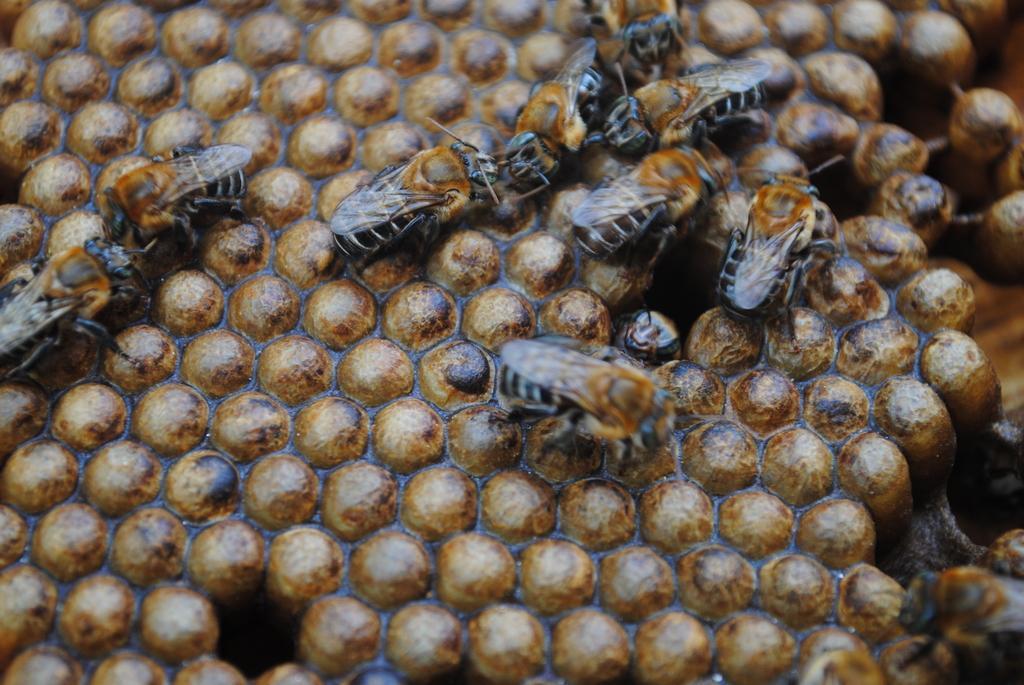Could you give a brief overview of what you see in this image? In this image I can see many honey bees which are in black and brown color. These are on the honeycomb which is in brown and black color. 